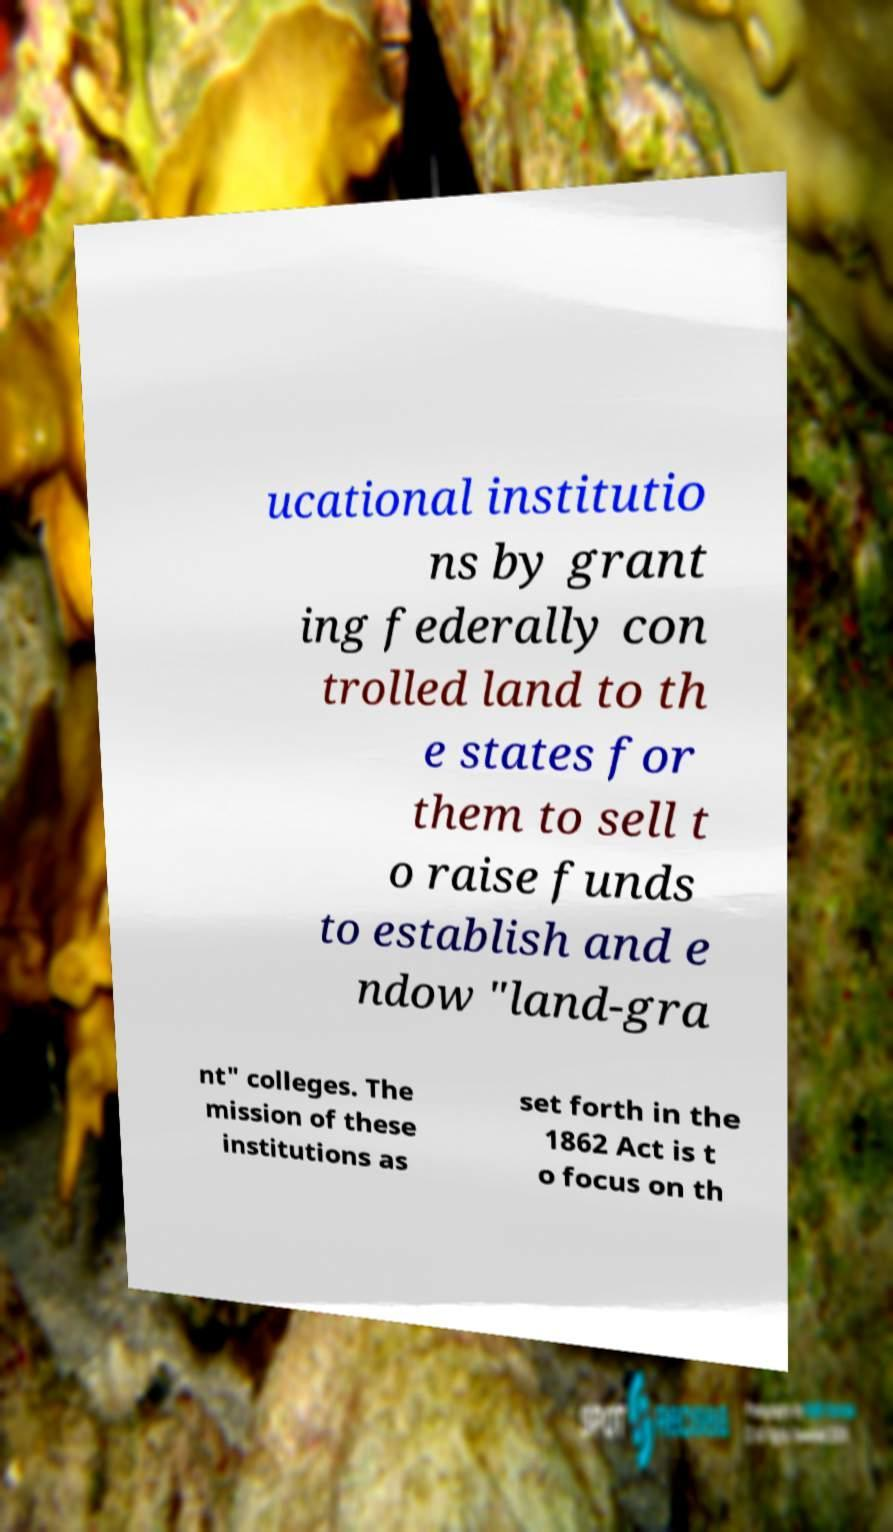Could you assist in decoding the text presented in this image and type it out clearly? ucational institutio ns by grant ing federally con trolled land to th e states for them to sell t o raise funds to establish and e ndow "land-gra nt" colleges. The mission of these institutions as set forth in the 1862 Act is t o focus on th 